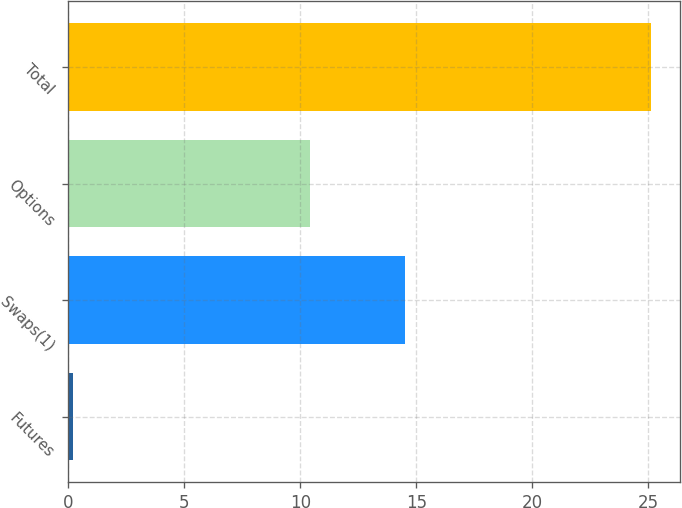Convert chart. <chart><loc_0><loc_0><loc_500><loc_500><bar_chart><fcel>Futures<fcel>Swaps(1)<fcel>Options<fcel>Total<nl><fcel>0.2<fcel>14.5<fcel>10.4<fcel>25.1<nl></chart> 